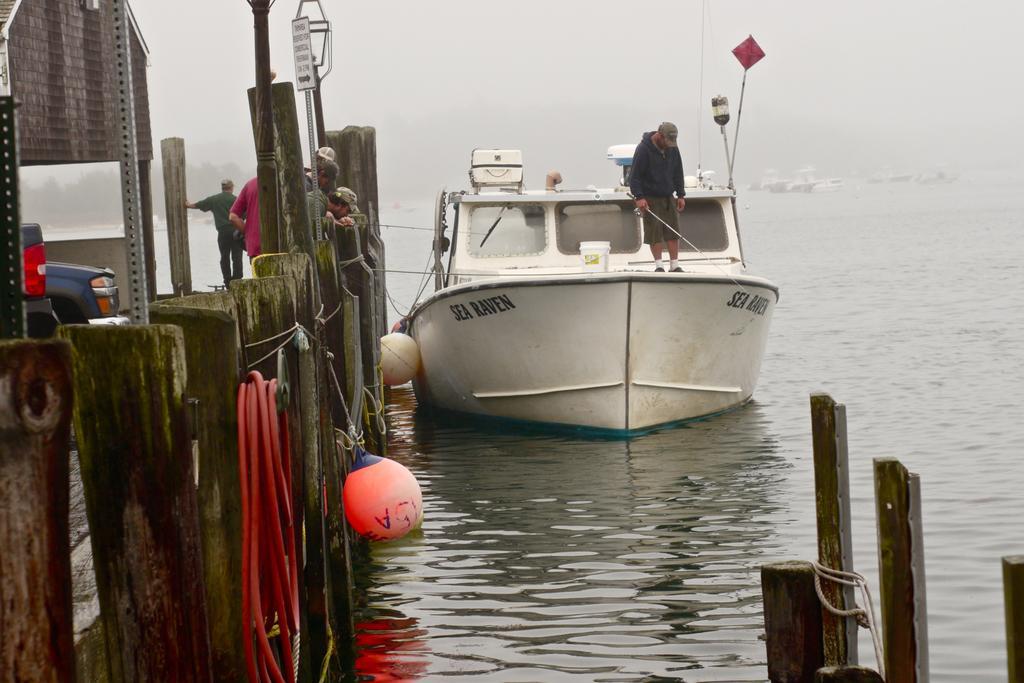Please provide a concise description of this image. In this image there is a white color boat. There is a person standing on it. To the left side of the image there are wooden poles. There are people standing. At the bottom of the image there is water. In the background of the image there are ships, trees. 